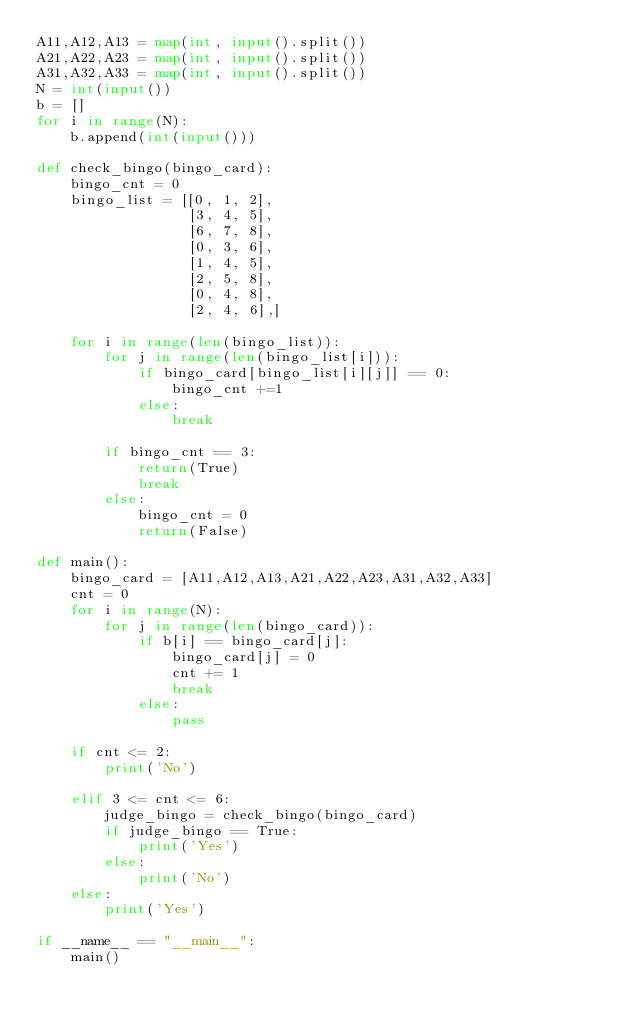<code> <loc_0><loc_0><loc_500><loc_500><_Python_>A11,A12,A13 = map(int, input().split())
A21,A22,A23 = map(int, input().split())
A31,A32,A33 = map(int, input().split())
N = int(input())
b = []
for i in range(N):
    b.append(int(input()))

def check_bingo(bingo_card):
    bingo_cnt = 0
    bingo_list = [[0, 1, 2],
                  [3, 4, 5],
                  [6, 7, 8],
                  [0, 3, 6],
                  [1, 4, 5],
                  [2, 5, 8],
                  [0, 4, 8],
                  [2, 4, 6],]    

    for i in range(len(bingo_list)):
        for j in range(len(bingo_list[i])):
            if bingo_card[bingo_list[i][j]] == 0:
                bingo_cnt +=1
            else:
                break
        
        if bingo_cnt == 3:
            return(True)
            break
        else:
            bingo_cnt = 0
            return(False)

def main():
    bingo_card = [A11,A12,A13,A21,A22,A23,A31,A32,A33]
    cnt = 0
    for i in range(N):
        for j in range(len(bingo_card)):
            if b[i] == bingo_card[j]:
                bingo_card[j] = 0
                cnt += 1
                break
            else:
                pass

    if cnt <= 2:
        print('No')                
        
    elif 3 <= cnt <= 6:
        judge_bingo = check_bingo(bingo_card)
        if judge_bingo == True:
            print('Yes')
        else:
            print('No')
    else:
        print('Yes')                
    
if __name__ == "__main__":
    main()

</code> 